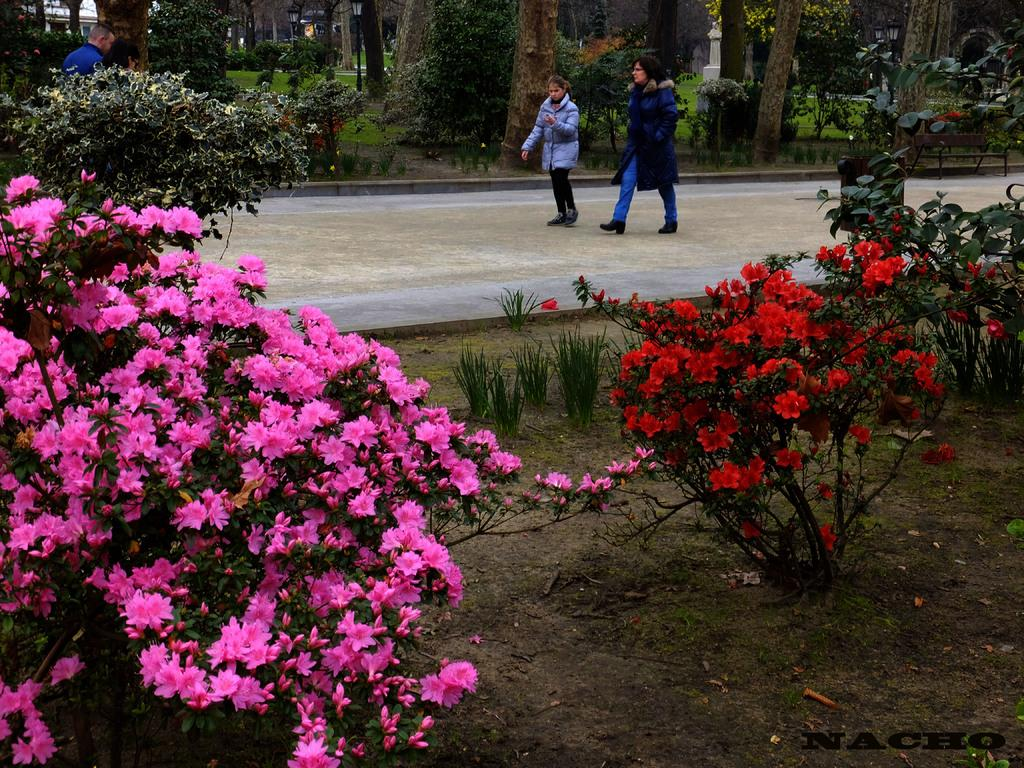What type of plants can be seen in the image? There are flower plants in the image. What else can be seen on the ground in the image? There is grass in the image. Can you describe the ground in the image? The ground is visible in the image. What is located at the top of the image? There are people, trees, and plants at the top of the image. What is the walkway used for in the image? A woman and a girl are walking on the walkway. What type of jeans is the machine wearing in the image? There is no machine or jeans present in the image. What is the spark doing in the image? There is no spark present in the image. 